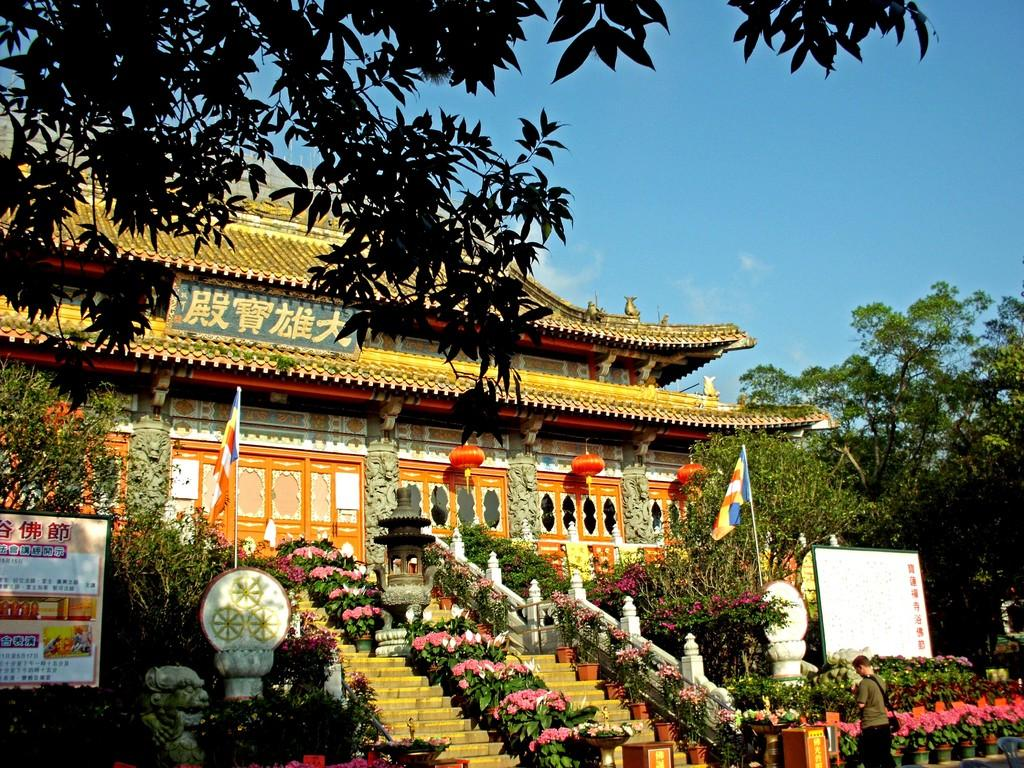What type of building is in the image? There is a temple in the image. What can be seen in front of the temple? There are many plants and trees in front of the temple. Is there anyone else in the image besides the temple? Yes, there is a person standing on the right side of the image. What is visible above the temple? The sky is visible above the temple. What account number does the person standing on the right side of the image have? There is no information about an account number in the image. 